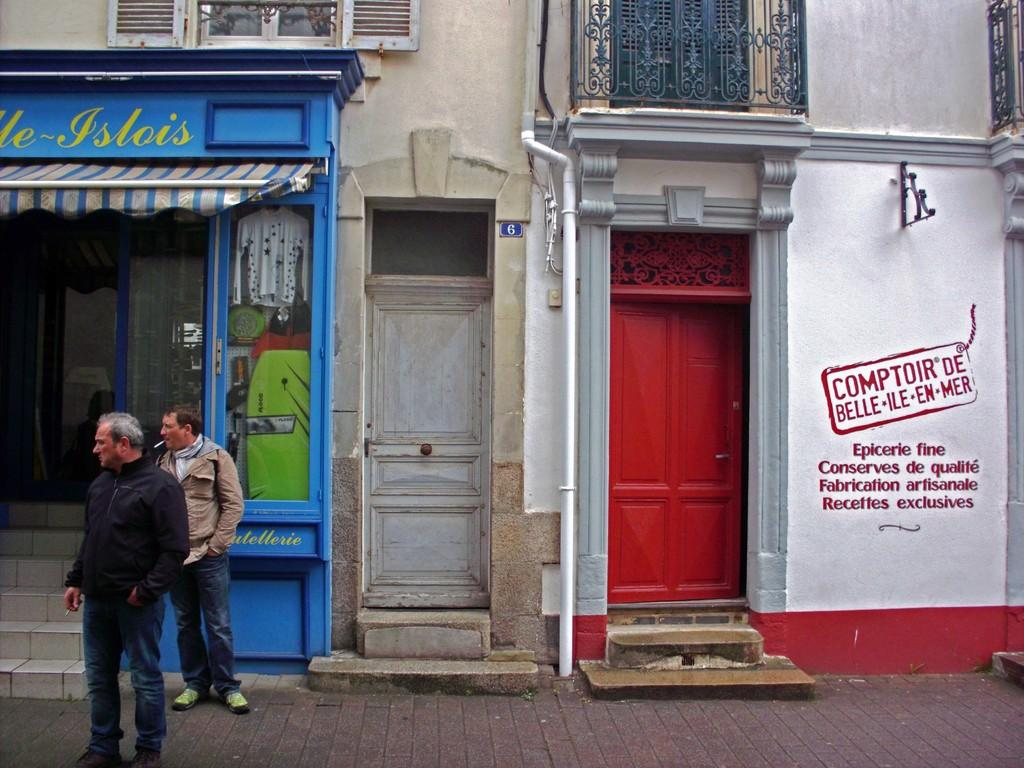How many people are in the image? There are two people standing in the image. Where are the people standing? The people are standing on a pavement. What can be seen in the background of the image? There are buildings in the background of the image. What feature do the buildings have? The buildings have doors. Can you see any impulses in the image? There is no mention of impulses in the image, so it cannot be determined if any are present. Is there a kite flying in the image? There is no kite visible in the image. 